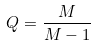<formula> <loc_0><loc_0><loc_500><loc_500>Q = \frac { M } { M - 1 }</formula> 